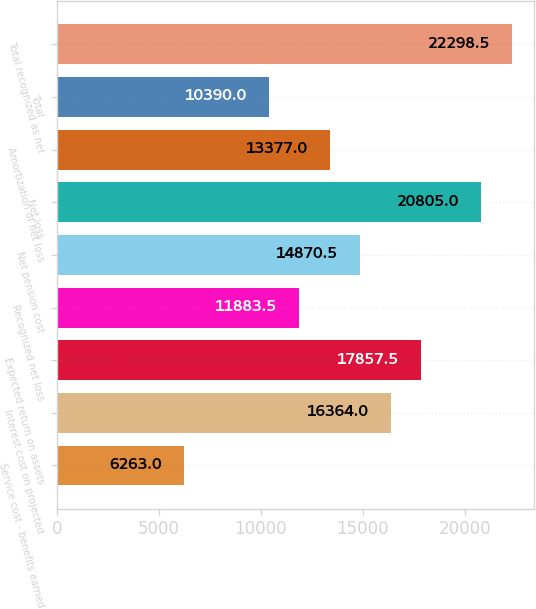Convert chart to OTSL. <chart><loc_0><loc_0><loc_500><loc_500><bar_chart><fcel>Service cost - benefits earned<fcel>Interest cost on projected<fcel>Expected return on assets<fcel>Recognized net loss<fcel>Net pension cost<fcel>Net loss<fcel>Amortization of net loss<fcel>Total<fcel>Total recognized as net<nl><fcel>6263<fcel>16364<fcel>17857.5<fcel>11883.5<fcel>14870.5<fcel>20805<fcel>13377<fcel>10390<fcel>22298.5<nl></chart> 